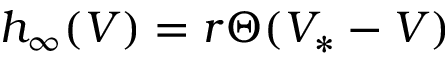<formula> <loc_0><loc_0><loc_500><loc_500>h _ { \infty } ( V ) = r \Theta ( V _ { * } - V )</formula> 